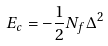<formula> <loc_0><loc_0><loc_500><loc_500>E _ { c } = - \frac { 1 } { 2 } N _ { f } \Delta ^ { 2 }</formula> 